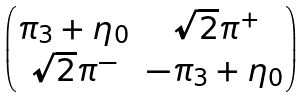<formula> <loc_0><loc_0><loc_500><loc_500>\begin{pmatrix} \pi _ { 3 } + \eta _ { 0 } & \sqrt { 2 } \pi ^ { + } \\ \sqrt { 2 } \pi ^ { - } & - \pi _ { 3 } + \eta _ { 0 } \end{pmatrix}</formula> 